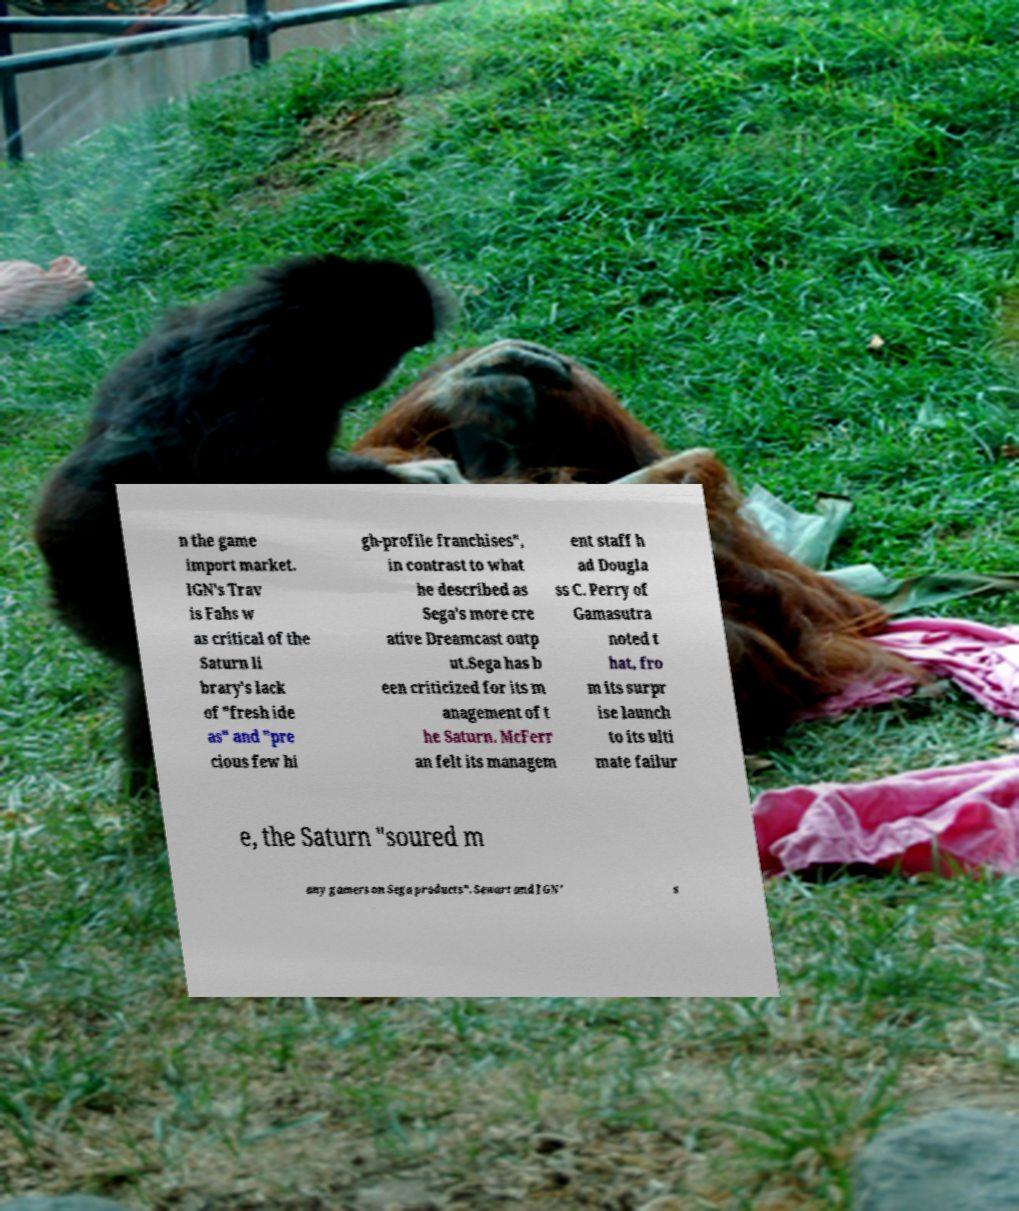For documentation purposes, I need the text within this image transcribed. Could you provide that? n the game import market. IGN's Trav is Fahs w as critical of the Saturn li brary's lack of "fresh ide as" and "pre cious few hi gh-profile franchises", in contrast to what he described as Sega's more cre ative Dreamcast outp ut.Sega has b een criticized for its m anagement of t he Saturn. McFerr an felt its managem ent staff h ad Dougla ss C. Perry of Gamasutra noted t hat, fro m its surpr ise launch to its ulti mate failur e, the Saturn "soured m any gamers on Sega products". Sewart and IGN' s 